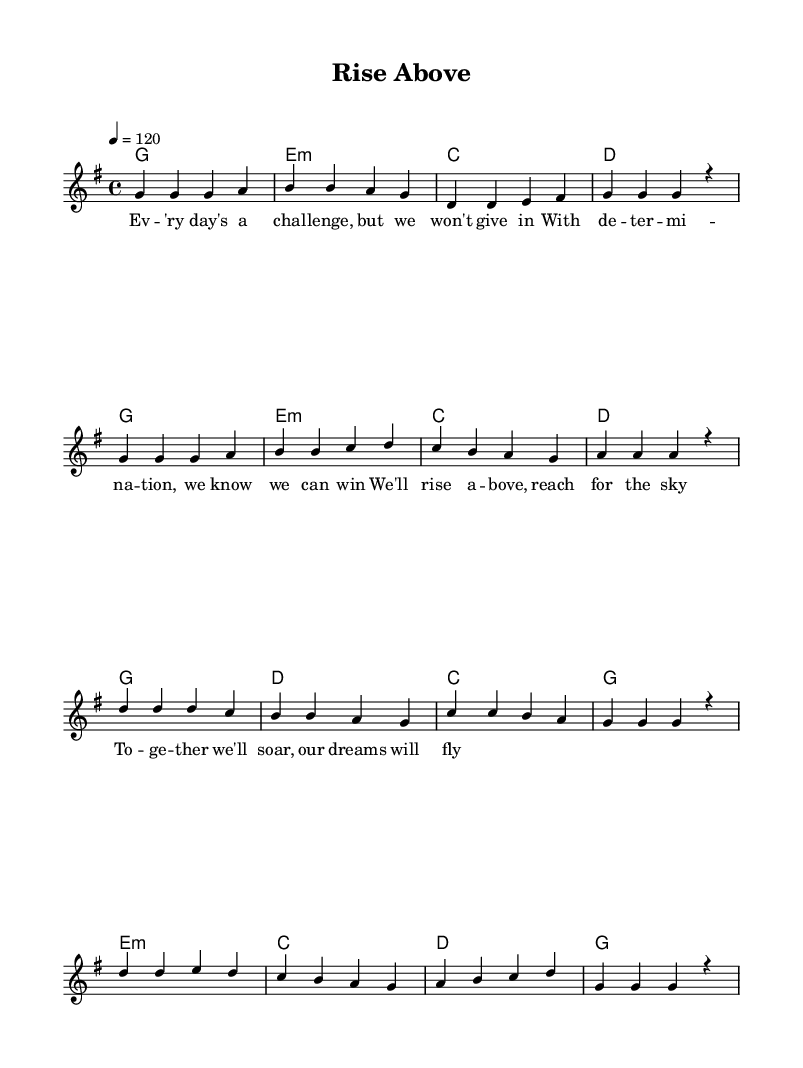What is the key signature of this music? The key signature is G major, which has one sharp (F#). This is determined by looking at the key signature indicated at the beginning of the sheet music.
Answer: G major What is the time signature of this piece? The time signature is 4/4, meaning there are four beats in each measure and the quarter note gets one beat. This can be found at the beginning of the piece where the time signature is explicitly stated.
Answer: 4/4 What is the tempo marking for this song? The tempo marking is 120 beats per minute, indicated as "4 = 120" in the tempo section of the global block. This indicates how fast the piece should be played.
Answer: 120 What is the primary theme of the lyrics in the verse? The theme of the lyrics is about facing challenges with determination. This can be deduced by reading the lyrics, which mention overcoming challenges and the spirit to win.
Answer: Overcoming challenges How many measures are in the chorus section? There are eight measures in the chorus section as can be counted directly from the sheet music where the chorus starts and ends, distinguishing it from the verse.
Answer: Eight What chord progression is used in the verse? The chord progression in the verse is G, E minor, C, D. This is found by looking at the chord symbols written above the melody in the verse section.
Answer: G, E minor, C, D 